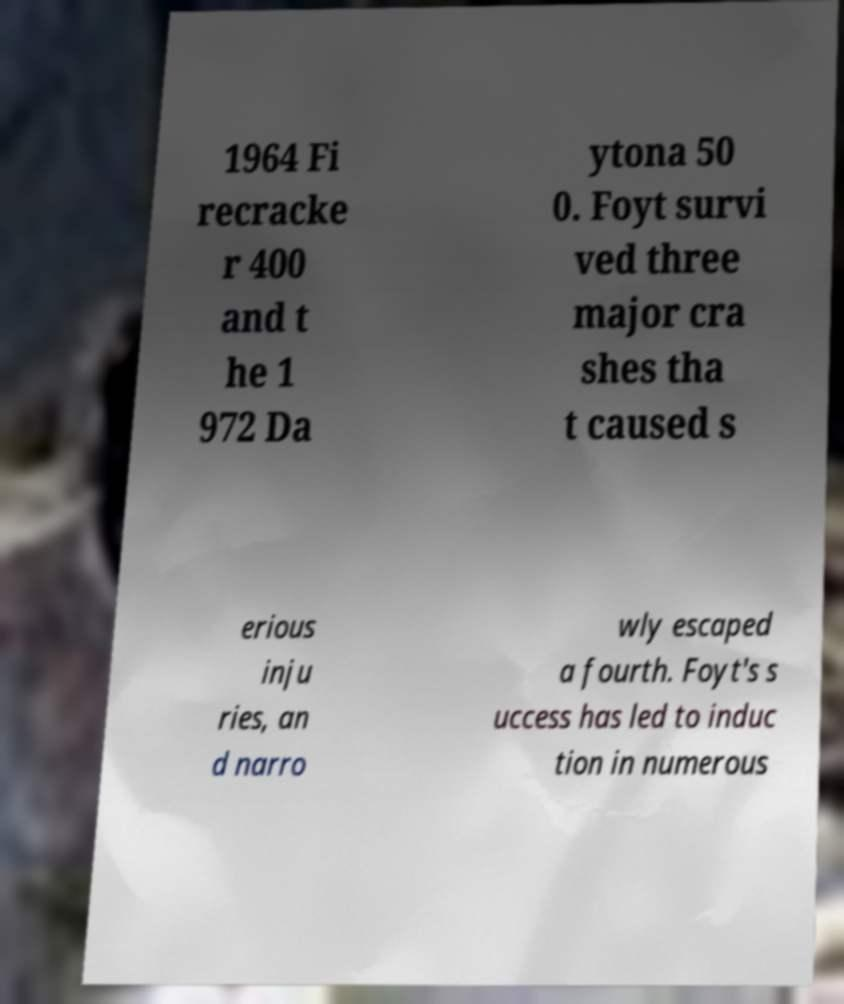I need the written content from this picture converted into text. Can you do that? 1964 Fi recracke r 400 and t he 1 972 Da ytona 50 0. Foyt survi ved three major cra shes tha t caused s erious inju ries, an d narro wly escaped a fourth. Foyt's s uccess has led to induc tion in numerous 